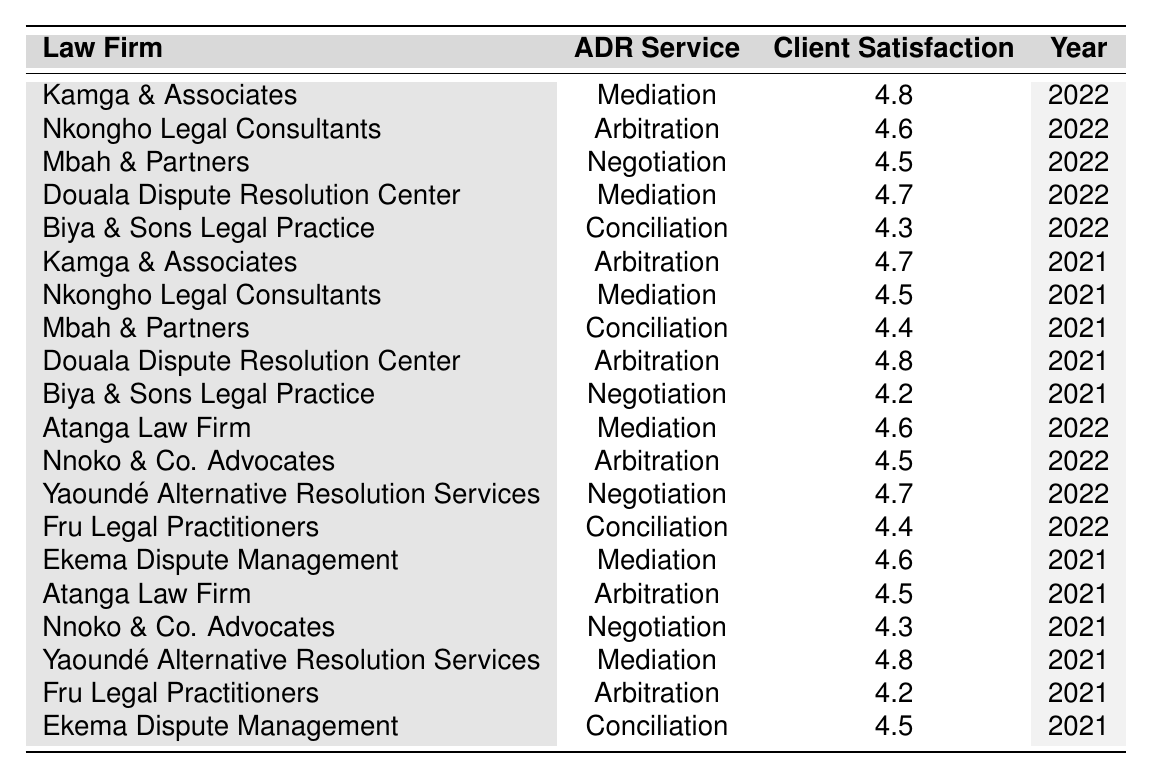What is the highest client satisfaction rating for mediation services in 2022? The table shows that the highest client satisfaction rating for mediation services in 2022 is provided by Kamga & Associates with a rating of 4.8.
Answer: 4.8 Which law firm provided arbitration services in 2021 with a rating of 4.8? According to the table, Douala Dispute Resolution Center provided arbitration services in 2021 with a client satisfaction rating of 4.8.
Answer: Douala Dispute Resolution Center How many law firms offered negotiation services in 2022? The table shows three law firms offering negotiation services in 2022: Mbah & Partners, Yaoundé Alternative Resolution Services, and Biya & Sons Legal Practice.
Answer: 3 What is the average client satisfaction rating for all ADR services in 2022? To find the average, we sum the ratings for 2022: (4.8 + 4.6 + 4.5 + 4.7 + 4.3 + 4.6 + 4.5 + 4.7 + 4.4) = 36.6, then divide by the number of entries (9), which gives us an average rating of 4.07.
Answer: 4.07 Did any law firm receive a client satisfaction rating below 4 in any service? Reviewing the table, no law firm received a client satisfaction rating below 4 in any of the listed ADR services.
Answer: No Which ADR service had the lowest client satisfaction rating in 2021? Looking at the 2021 ratings for each service, the lowest rating is for Biya & Sons Legal Practice in negotiation with a rating of 4.2.
Answer: Negotiation What was the difference in client satisfaction ratings for arbitration services between 2021 and 2022 provided by Nkongho Legal Consultants? Nkongho Legal Consultants had a rating of 4.5 for arbitration in 2022 and 4.5 in 2021. The difference is 4.5 - 4.5 = 0.
Answer: 0 Which law firm had the highest client satisfaction rating for conciliation services overall? The table indicates that the highest rating for conciliation services is 4.5, provided by both Ekema Dispute Management and Mbah & Partners in 2021.
Answer: 4.5 How many law firms had ratings of 4.6 or higher for mediation services in 2021? The firms with ratings of 4.6 or higher for mediation in 2021 are Kamga & Associates (4.6), Yaoundé Alternative Resolution Services (4.8), and Ekema Dispute Management (4.6), totaling three firms.
Answer: 3 Was there a change in the client satisfaction rating for mediation services from 2021 to 2022? Comparing the table data, Kamga & Associates improved from 4.6 in 2021 to 4.8 in 2022, and Yaoundé Alternative Resolution Services stayed the same at 4.8. Thus, there was an overall positive shift in ratings.
Answer: Yes 